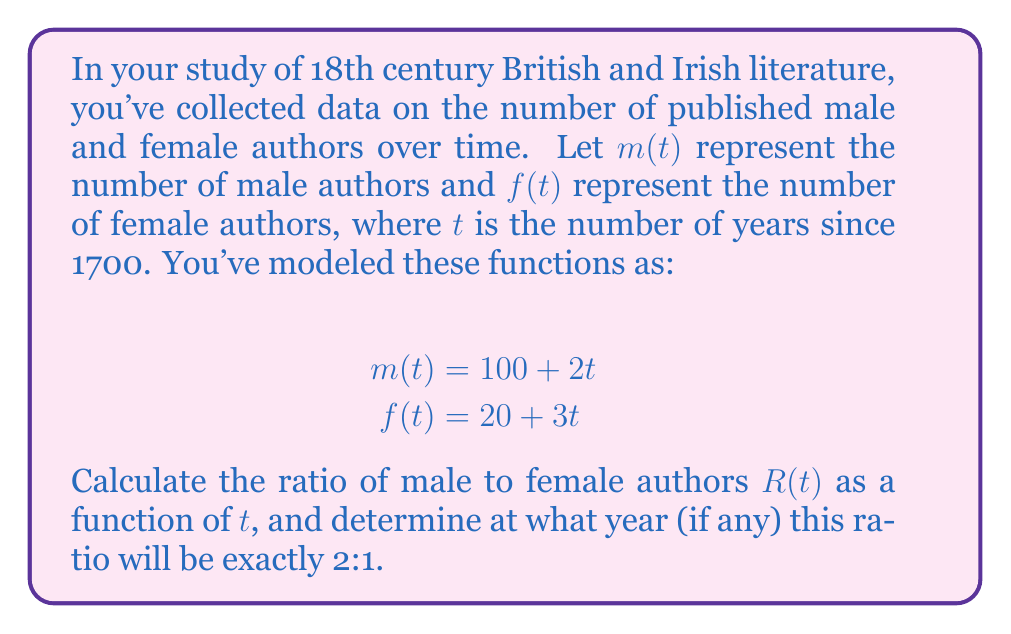Solve this math problem. Let's approach this step-by-step:

1) The ratio of male to female authors, $R(t)$, is given by:

   $$R(t) = \frac{m(t)}{f(t)} = \frac{100 + 2t}{20 + 3t}$$

2) We want to find when this ratio equals 2:1, so we set up the equation:

   $$\frac{100 + 2t}{20 + 3t} = 2$$

3) Cross-multiply:

   $$(100 + 2t) = 2(20 + 3t)$$

4) Expand the right side:

   $$100 + 2t = 40 + 6t$$

5) Subtract 100 from both sides:

   $$2t = -60 + 6t$$

6) Subtract 2t from both sides:

   $$0 = -60 + 4t$$

7) Add 60 to both sides:

   $$60 = 4t$$

8) Divide both sides by 4:

   $$15 = t$$

9) Therefore, the ratio will be 2:1 when $t = 15$, which corresponds to the year 1715.

10) To verify, we can plug this value back into our original functions:

    $m(15) = 100 + 2(15) = 130$
    $f(15) = 20 + 3(15) = 65$

    Indeed, $130 / 65 = 2$, confirming our result.
Answer: $R(t) = \frac{100 + 2t}{20 + 3t}$; 2:1 ratio occurs in 1715 